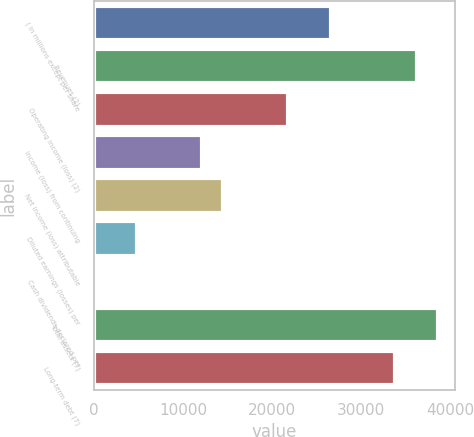Convert chart to OTSL. <chart><loc_0><loc_0><loc_500><loc_500><bar_chart><fcel>( in millions except per share<fcel>Revenues (2)<fcel>Operating income (loss) (2)<fcel>Income (loss) from continuing<fcel>Net income (loss) attributable<fcel>Diluted earnings (losses) per<fcel>Cash dividends declared per<fcel>Total assets (7)<fcel>Long-term debt (7)<nl><fcel>26553.9<fcel>36209.4<fcel>21726.1<fcel>12070.6<fcel>14484.5<fcel>4828.91<fcel>1.15<fcel>38623.3<fcel>33795.5<nl></chart> 